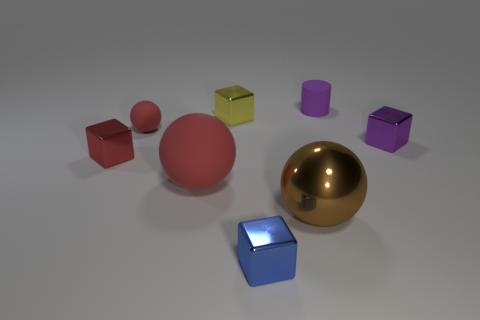Add 2 purple cylinders. How many objects exist? 10 Subtract all cylinders. How many objects are left? 7 Subtract all yellow spheres. Subtract all big things. How many objects are left? 6 Add 3 tiny yellow blocks. How many tiny yellow blocks are left? 4 Add 8 yellow objects. How many yellow objects exist? 9 Subtract 0 blue cylinders. How many objects are left? 8 